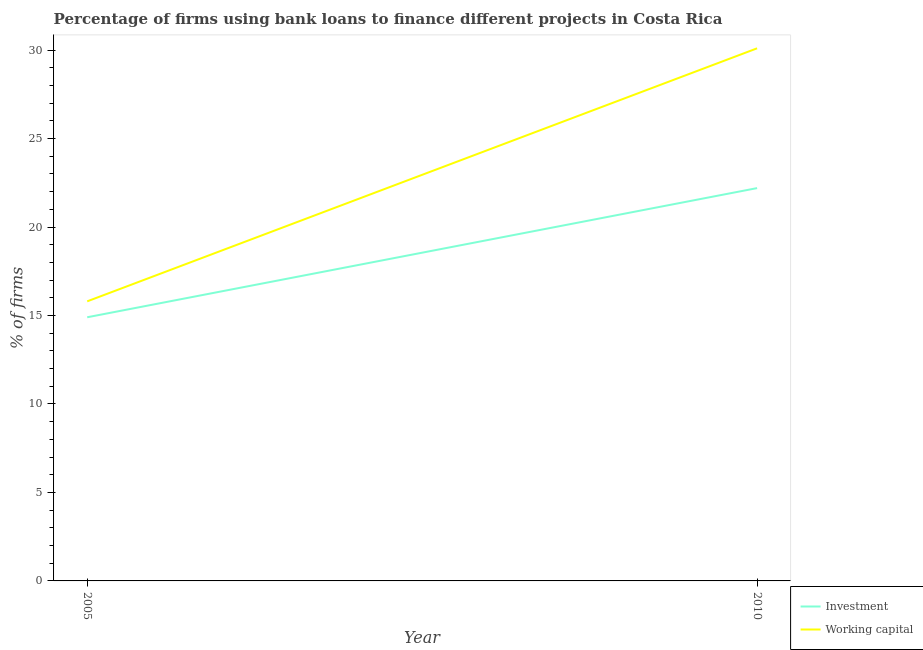What is the percentage of firms using banks to finance investment in 2010?
Ensure brevity in your answer.  22.2. Across all years, what is the maximum percentage of firms using banks to finance working capital?
Your answer should be compact. 30.1. In which year was the percentage of firms using banks to finance investment maximum?
Your answer should be very brief. 2010. In which year was the percentage of firms using banks to finance investment minimum?
Offer a very short reply. 2005. What is the total percentage of firms using banks to finance working capital in the graph?
Provide a succinct answer. 45.9. What is the difference between the percentage of firms using banks to finance working capital in 2005 and that in 2010?
Keep it short and to the point. -14.3. What is the difference between the percentage of firms using banks to finance investment in 2005 and the percentage of firms using banks to finance working capital in 2010?
Your response must be concise. -15.2. What is the average percentage of firms using banks to finance working capital per year?
Offer a very short reply. 22.95. In the year 2010, what is the difference between the percentage of firms using banks to finance working capital and percentage of firms using banks to finance investment?
Give a very brief answer. 7.9. In how many years, is the percentage of firms using banks to finance investment greater than 7 %?
Your answer should be compact. 2. What is the ratio of the percentage of firms using banks to finance investment in 2005 to that in 2010?
Your answer should be very brief. 0.67. In how many years, is the percentage of firms using banks to finance working capital greater than the average percentage of firms using banks to finance working capital taken over all years?
Make the answer very short. 1. Is the percentage of firms using banks to finance investment strictly less than the percentage of firms using banks to finance working capital over the years?
Offer a terse response. Yes. How many years are there in the graph?
Make the answer very short. 2. What is the difference between two consecutive major ticks on the Y-axis?
Keep it short and to the point. 5. Are the values on the major ticks of Y-axis written in scientific E-notation?
Keep it short and to the point. No. Does the graph contain any zero values?
Ensure brevity in your answer.  No. Does the graph contain grids?
Offer a terse response. No. Where does the legend appear in the graph?
Your response must be concise. Bottom right. How many legend labels are there?
Keep it short and to the point. 2. What is the title of the graph?
Give a very brief answer. Percentage of firms using bank loans to finance different projects in Costa Rica. What is the label or title of the Y-axis?
Provide a short and direct response. % of firms. What is the % of firms in Working capital in 2010?
Provide a short and direct response. 30.1. Across all years, what is the maximum % of firms of Working capital?
Provide a succinct answer. 30.1. Across all years, what is the minimum % of firms in Investment?
Provide a short and direct response. 14.9. What is the total % of firms in Investment in the graph?
Your answer should be compact. 37.1. What is the total % of firms in Working capital in the graph?
Offer a terse response. 45.9. What is the difference between the % of firms in Working capital in 2005 and that in 2010?
Provide a short and direct response. -14.3. What is the difference between the % of firms of Investment in 2005 and the % of firms of Working capital in 2010?
Ensure brevity in your answer.  -15.2. What is the average % of firms of Investment per year?
Keep it short and to the point. 18.55. What is the average % of firms of Working capital per year?
Make the answer very short. 22.95. In the year 2005, what is the difference between the % of firms in Investment and % of firms in Working capital?
Your response must be concise. -0.9. In the year 2010, what is the difference between the % of firms of Investment and % of firms of Working capital?
Offer a terse response. -7.9. What is the ratio of the % of firms of Investment in 2005 to that in 2010?
Give a very brief answer. 0.67. What is the ratio of the % of firms of Working capital in 2005 to that in 2010?
Your answer should be very brief. 0.52. What is the difference between the highest and the second highest % of firms in Investment?
Your answer should be very brief. 7.3. What is the difference between the highest and the second highest % of firms in Working capital?
Your answer should be very brief. 14.3. 